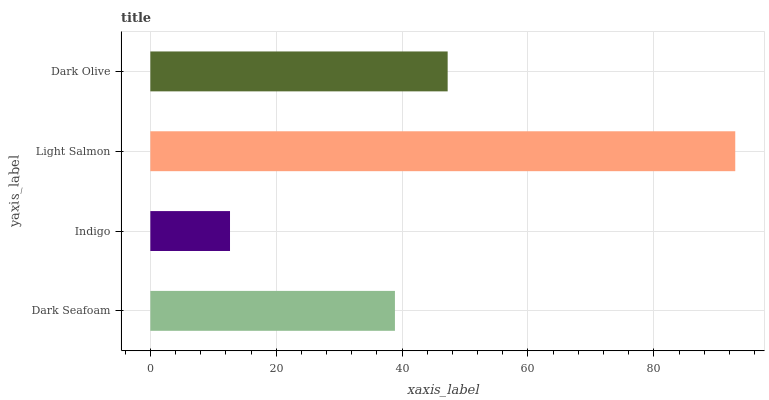Is Indigo the minimum?
Answer yes or no. Yes. Is Light Salmon the maximum?
Answer yes or no. Yes. Is Light Salmon the minimum?
Answer yes or no. No. Is Indigo the maximum?
Answer yes or no. No. Is Light Salmon greater than Indigo?
Answer yes or no. Yes. Is Indigo less than Light Salmon?
Answer yes or no. Yes. Is Indigo greater than Light Salmon?
Answer yes or no. No. Is Light Salmon less than Indigo?
Answer yes or no. No. Is Dark Olive the high median?
Answer yes or no. Yes. Is Dark Seafoam the low median?
Answer yes or no. Yes. Is Indigo the high median?
Answer yes or no. No. Is Dark Olive the low median?
Answer yes or no. No. 